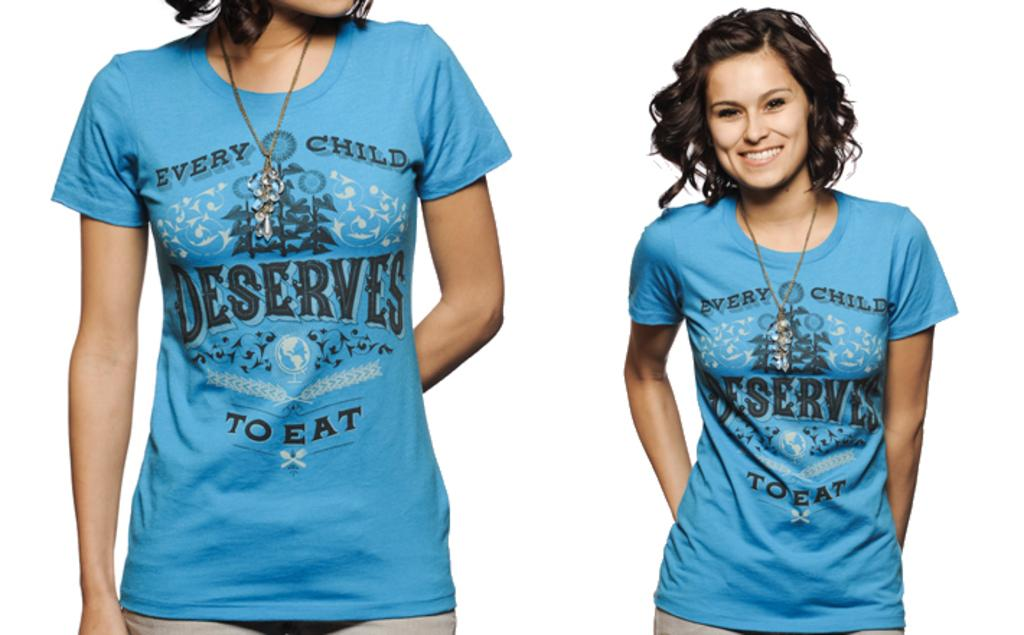<image>
Write a terse but informative summary of the picture. the word deserves that is on some blue shirts 